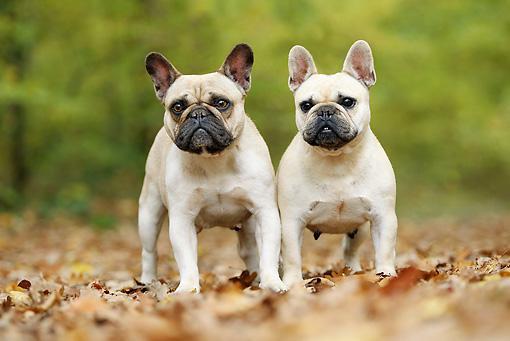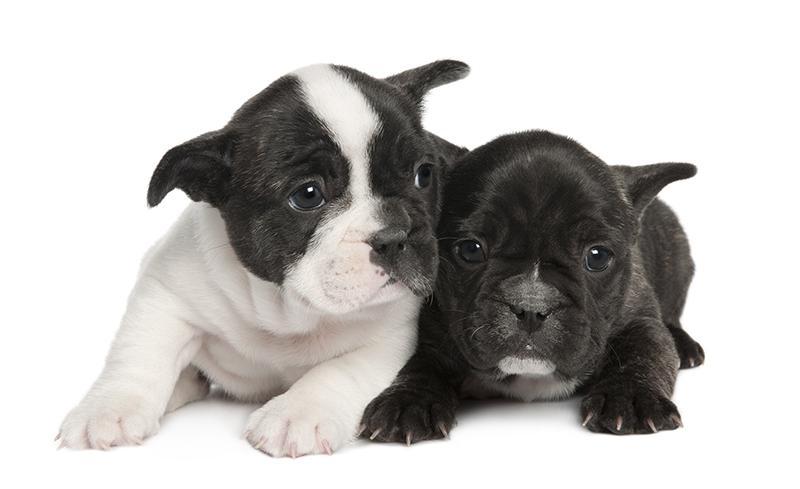The first image is the image on the left, the second image is the image on the right. For the images displayed, is the sentence "Two dogs are standing up in one of the images." factually correct? Answer yes or no. Yes. The first image is the image on the left, the second image is the image on the right. Analyze the images presented: Is the assertion "Each image contains two big-eared dogs, and one pair of dogs includes a mostly black one and a mostly white one." valid? Answer yes or no. Yes. 